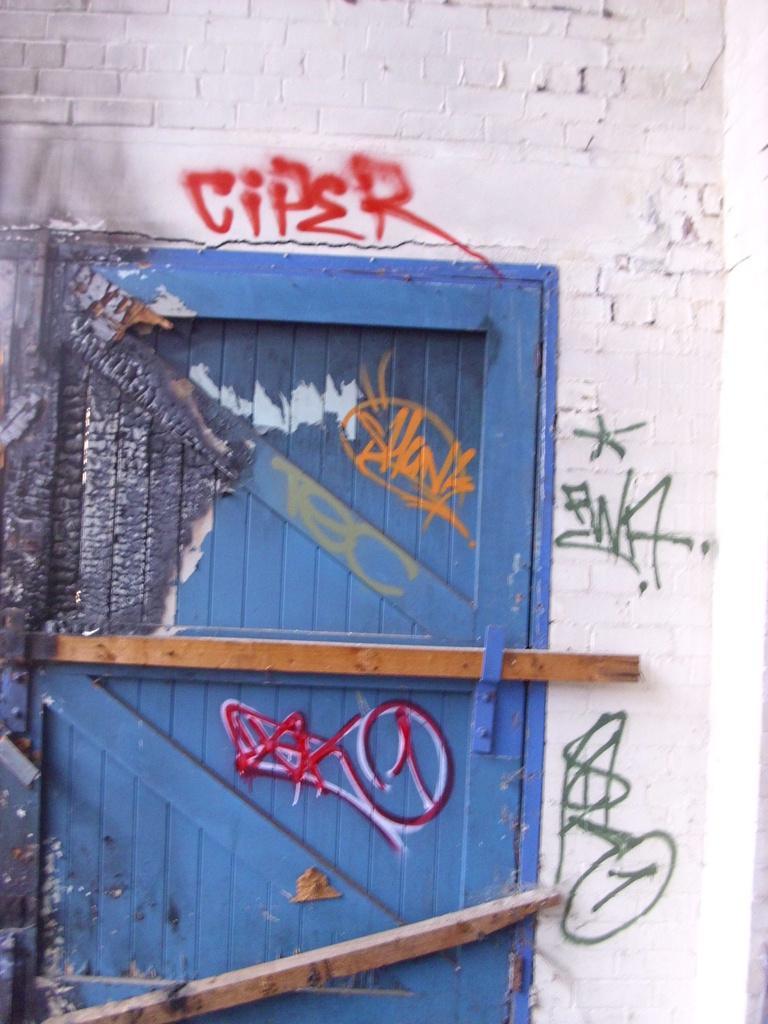Could you give a brief overview of what you see in this image? In this image we can see the door, wall and also the graffiti on the door and also wall. 